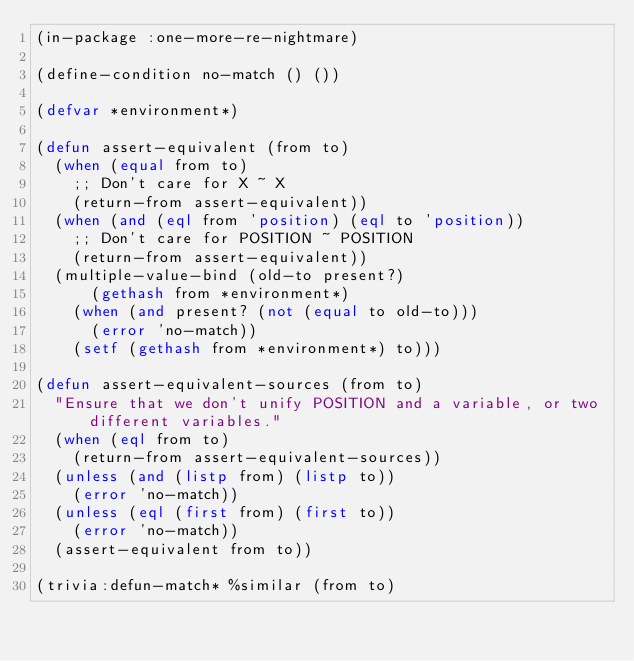<code> <loc_0><loc_0><loc_500><loc_500><_Lisp_>(in-package :one-more-re-nightmare)

(define-condition no-match () ())

(defvar *environment*)

(defun assert-equivalent (from to)
  (when (equal from to)
    ;; Don't care for X ~ X
    (return-from assert-equivalent))
  (when (and (eql from 'position) (eql to 'position))
    ;; Don't care for POSITION ~ POSITION
    (return-from assert-equivalent))
  (multiple-value-bind (old-to present?)
      (gethash from *environment*)
    (when (and present? (not (equal to old-to)))
      (error 'no-match))
    (setf (gethash from *environment*) to)))

(defun assert-equivalent-sources (from to)
  "Ensure that we don't unify POSITION and a variable, or two different variables."
  (when (eql from to)
    (return-from assert-equivalent-sources))
  (unless (and (listp from) (listp to))
    (error 'no-match))
  (unless (eql (first from) (first to))
    (error 'no-match))
  (assert-equivalent from to))

(trivia:defun-match* %similar (from to)</code> 